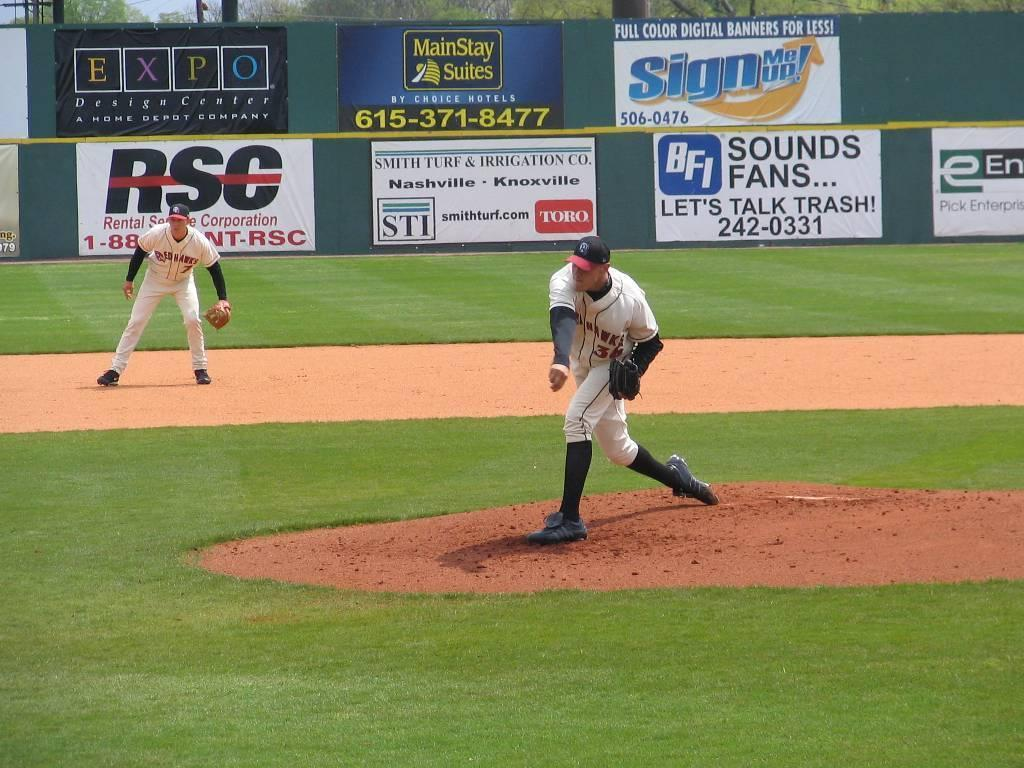<image>
Share a concise interpretation of the image provided. a man pitching with a sign in the back saying sign me up 